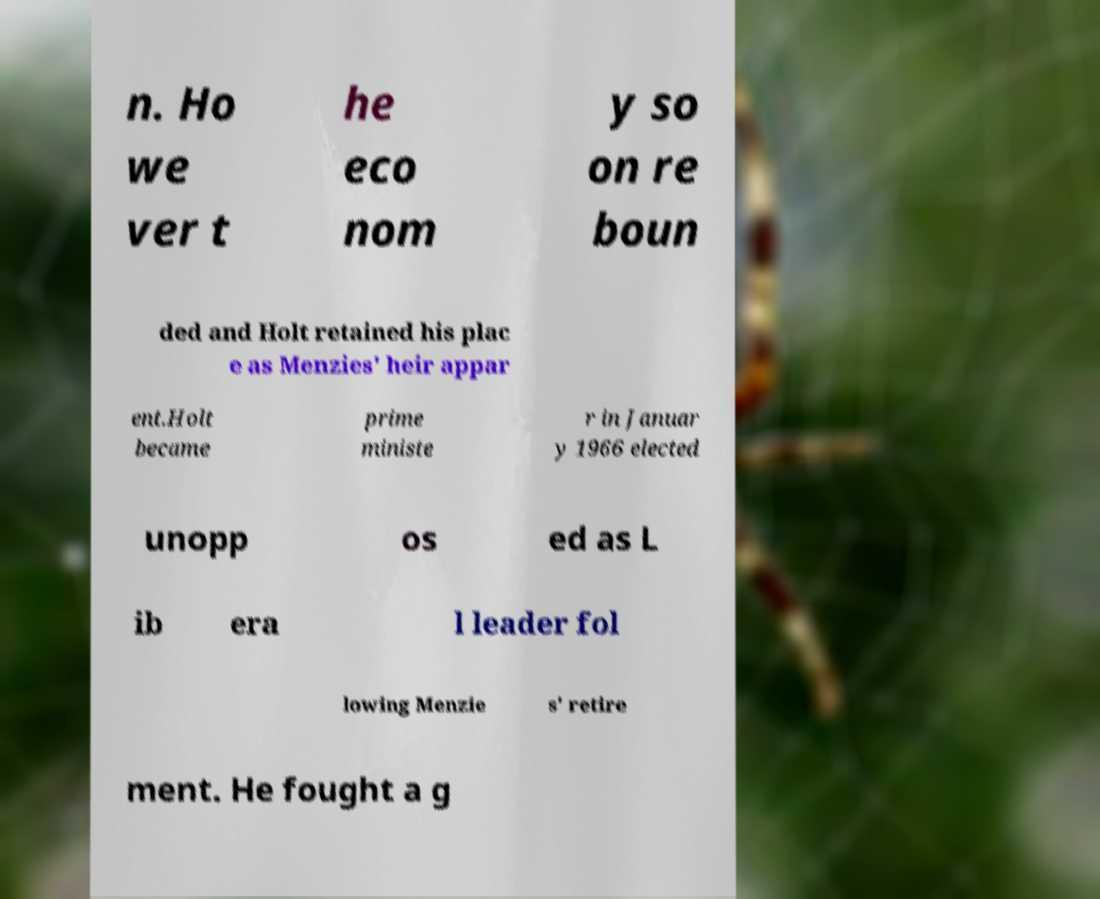Please read and relay the text visible in this image. What does it say? n. Ho we ver t he eco nom y so on re boun ded and Holt retained his plac e as Menzies' heir appar ent.Holt became prime ministe r in Januar y 1966 elected unopp os ed as L ib era l leader fol lowing Menzie s' retire ment. He fought a g 